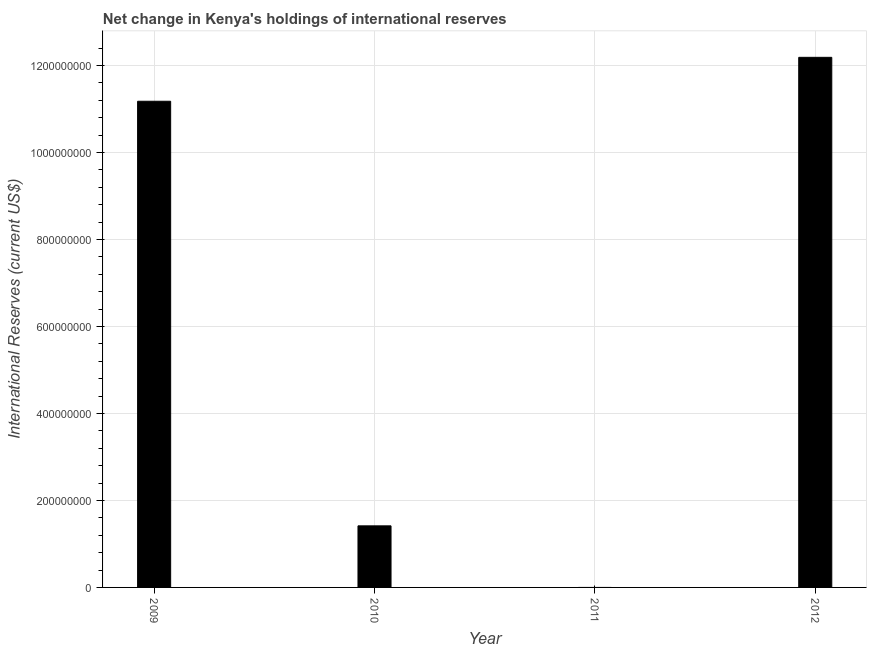Does the graph contain any zero values?
Make the answer very short. Yes. Does the graph contain grids?
Offer a very short reply. Yes. What is the title of the graph?
Offer a very short reply. Net change in Kenya's holdings of international reserves. What is the label or title of the X-axis?
Your answer should be very brief. Year. What is the label or title of the Y-axis?
Offer a very short reply. International Reserves (current US$). What is the reserves and related items in 2012?
Offer a terse response. 1.22e+09. Across all years, what is the maximum reserves and related items?
Your response must be concise. 1.22e+09. What is the sum of the reserves and related items?
Your response must be concise. 2.48e+09. What is the difference between the reserves and related items in 2009 and 2010?
Provide a short and direct response. 9.76e+08. What is the average reserves and related items per year?
Your answer should be very brief. 6.20e+08. What is the median reserves and related items?
Ensure brevity in your answer.  6.30e+08. In how many years, is the reserves and related items greater than 1120000000 US$?
Make the answer very short. 1. What is the ratio of the reserves and related items in 2009 to that in 2010?
Keep it short and to the point. 7.89. What is the difference between the highest and the second highest reserves and related items?
Your answer should be very brief. 1.01e+08. What is the difference between the highest and the lowest reserves and related items?
Your answer should be compact. 1.22e+09. In how many years, is the reserves and related items greater than the average reserves and related items taken over all years?
Offer a terse response. 2. How many bars are there?
Your response must be concise. 3. Are the values on the major ticks of Y-axis written in scientific E-notation?
Your response must be concise. No. What is the International Reserves (current US$) of 2009?
Your answer should be very brief. 1.12e+09. What is the International Reserves (current US$) in 2010?
Your answer should be compact. 1.42e+08. What is the International Reserves (current US$) in 2011?
Provide a short and direct response. 0. What is the International Reserves (current US$) in 2012?
Ensure brevity in your answer.  1.22e+09. What is the difference between the International Reserves (current US$) in 2009 and 2010?
Offer a terse response. 9.76e+08. What is the difference between the International Reserves (current US$) in 2009 and 2012?
Your answer should be very brief. -1.01e+08. What is the difference between the International Reserves (current US$) in 2010 and 2012?
Your answer should be compact. -1.08e+09. What is the ratio of the International Reserves (current US$) in 2009 to that in 2010?
Your answer should be compact. 7.89. What is the ratio of the International Reserves (current US$) in 2009 to that in 2012?
Give a very brief answer. 0.92. What is the ratio of the International Reserves (current US$) in 2010 to that in 2012?
Your answer should be very brief. 0.12. 